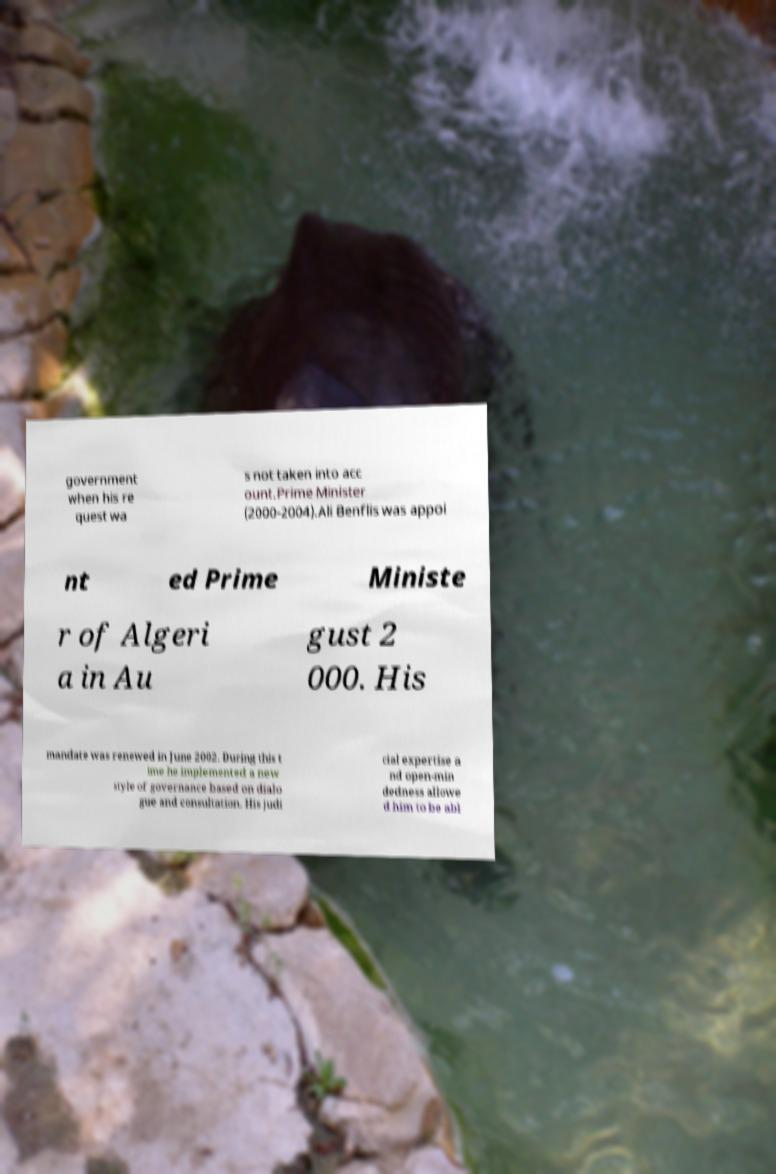Could you extract and type out the text from this image? government when his re quest wa s not taken into acc ount.Prime Minister (2000-2004).Ali Benflis was appoi nt ed Prime Ministe r of Algeri a in Au gust 2 000. His mandate was renewed in June 2002. During this t ime he implemented a new style of governance based on dialo gue and consultation. His judi cial expertise a nd open-min dedness allowe d him to be abl 